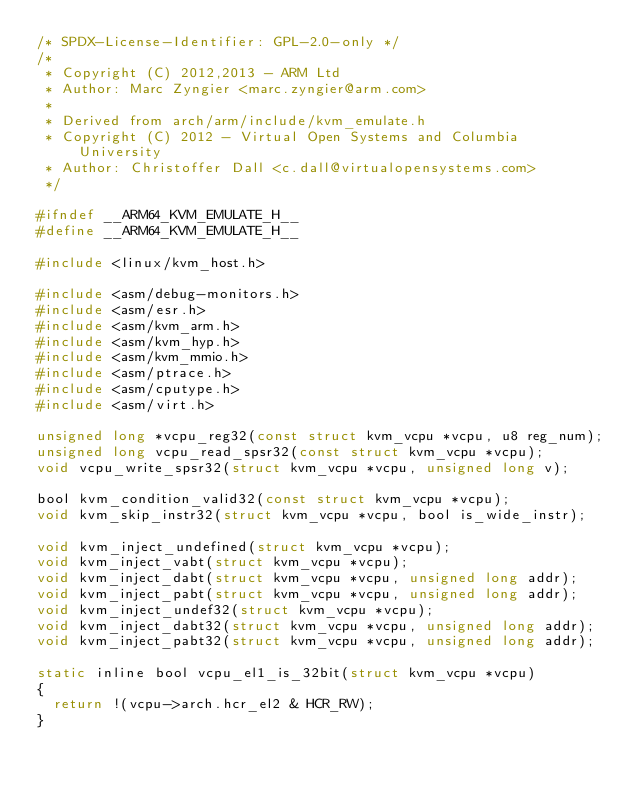Convert code to text. <code><loc_0><loc_0><loc_500><loc_500><_C_>/* SPDX-License-Identifier: GPL-2.0-only */
/*
 * Copyright (C) 2012,2013 - ARM Ltd
 * Author: Marc Zyngier <marc.zyngier@arm.com>
 *
 * Derived from arch/arm/include/kvm_emulate.h
 * Copyright (C) 2012 - Virtual Open Systems and Columbia University
 * Author: Christoffer Dall <c.dall@virtualopensystems.com>
 */

#ifndef __ARM64_KVM_EMULATE_H__
#define __ARM64_KVM_EMULATE_H__

#include <linux/kvm_host.h>

#include <asm/debug-monitors.h>
#include <asm/esr.h>
#include <asm/kvm_arm.h>
#include <asm/kvm_hyp.h>
#include <asm/kvm_mmio.h>
#include <asm/ptrace.h>
#include <asm/cputype.h>
#include <asm/virt.h>

unsigned long *vcpu_reg32(const struct kvm_vcpu *vcpu, u8 reg_num);
unsigned long vcpu_read_spsr32(const struct kvm_vcpu *vcpu);
void vcpu_write_spsr32(struct kvm_vcpu *vcpu, unsigned long v);

bool kvm_condition_valid32(const struct kvm_vcpu *vcpu);
void kvm_skip_instr32(struct kvm_vcpu *vcpu, bool is_wide_instr);

void kvm_inject_undefined(struct kvm_vcpu *vcpu);
void kvm_inject_vabt(struct kvm_vcpu *vcpu);
void kvm_inject_dabt(struct kvm_vcpu *vcpu, unsigned long addr);
void kvm_inject_pabt(struct kvm_vcpu *vcpu, unsigned long addr);
void kvm_inject_undef32(struct kvm_vcpu *vcpu);
void kvm_inject_dabt32(struct kvm_vcpu *vcpu, unsigned long addr);
void kvm_inject_pabt32(struct kvm_vcpu *vcpu, unsigned long addr);

static inline bool vcpu_el1_is_32bit(struct kvm_vcpu *vcpu)
{
	return !(vcpu->arch.hcr_el2 & HCR_RW);
}
</code> 